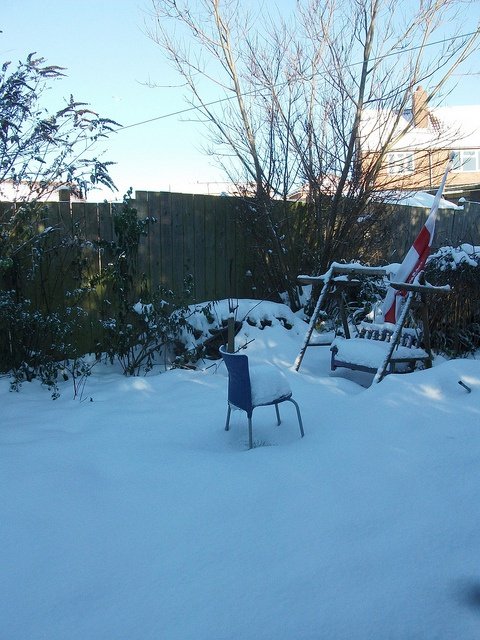Describe the objects in this image and their specific colors. I can see chair in lightblue, navy, gray, and blue tones and bench in lightblue, gray, navy, and black tones in this image. 